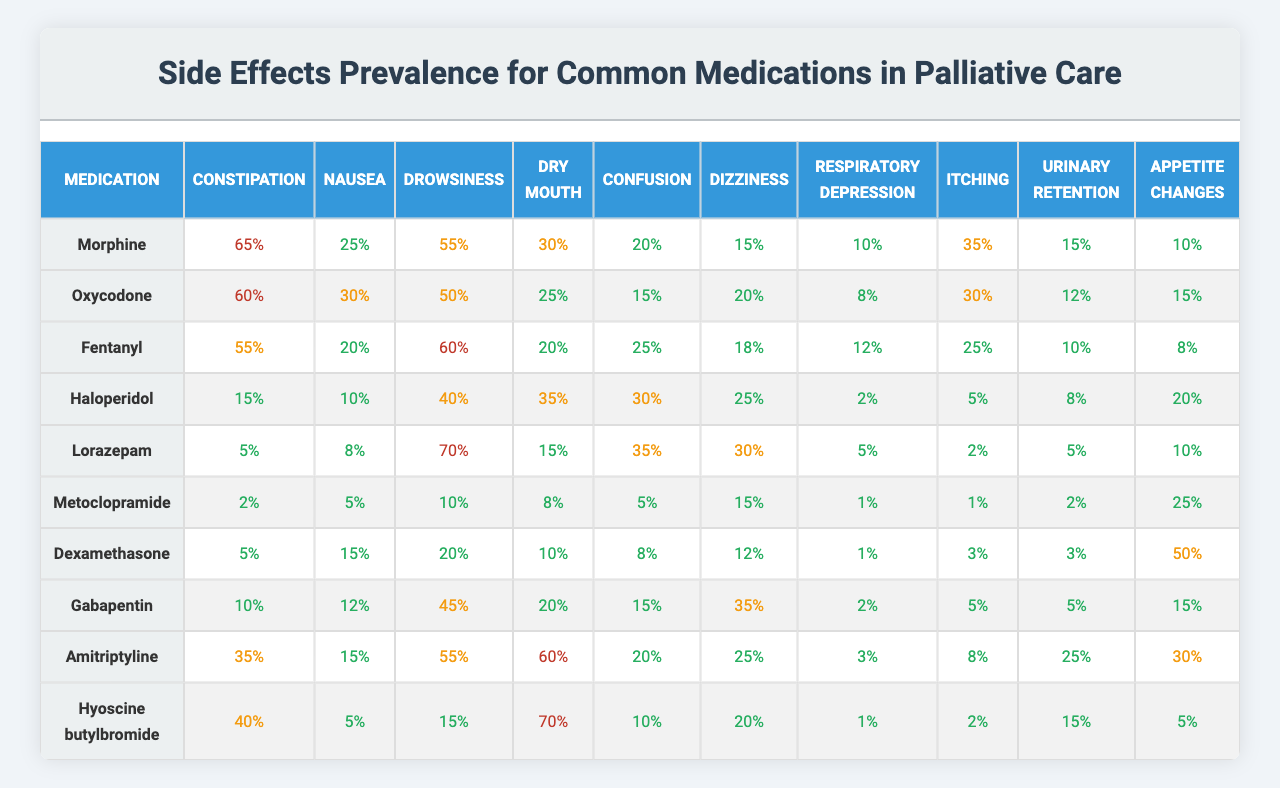What is the prevalence of constipation for Morphine? The table indicates that the prevalence of constipation for Morphine is 65%.
Answer: 65% Which medication has the highest prevalence of drowsiness? By checking the drowsiness values across all medications, Fentanyl has the highest prevalence at 60%.
Answer: Fentanyl Does Lorazepam cause more nausea than Metoclopramide? The table shows that Lorazepam has a prevalence of nausea at 8%, while Metoclopramide has a prevalence of 5%. Therefore, yes, Lorazepam causes more nausea.
Answer: Yes What is the total prevalence of respiratory depression for both Morphine and Oxycodone? The prevalence of respiratory depression for Morphine is 10%, and for Oxycodone is 8%. Adding these gives 10% + 8% = 18%.
Answer: 18% Which medication has the lowest prevalence of appetite changes, and what is that percentage? Reviewing the table, Metoclopramide has the lowest prevalence of appetite changes at 25%.
Answer: Metoclopramide, 25% Calculate the average prevalence of confusion across all medications. The values for confusion are: 20, 15, 25, 30, 35, 5, 8, 15, 20, and 10. Summing these gives 20 + 15 + 25 + 30 + 35 + 5 + 8 + 15 + 20 + 10 =  3. The average is then calculated as the total (180) divided by the number of medications (10), which is 18%.
Answer: 18% Is drowsiness more prevalent in Amitriptyline or Gabapentin? Amitriptyline has a drowsiness prevalence of 55%, whereas Gabapentin's is 45%. Comparing these figures shows that Amitriptyline has a higher prevalence.
Answer: Amitriptyline What is the prevalence of dry mouth for Hyoscine butylbromide? According to the table, Hyoscine butylbromide has a prevalence of dry mouth at 70%.
Answer: 70% Which medication has a prevalence of urinary retention lower than 10%? Looking at the urinary retention values, both Fentanyl (10%) and Dexamethasone (3%) have lower prevalence levels, meaning only Dexamethasone fits the criteria.
Answer: Dexamethasone What is the difference in the prevalence of itching between Oxycodone and Haloperidol? The prevalence of itching for Oxycodone is 30%, and for Haloperidol, it is 5%. The difference is 30% - 5% = 25%.
Answer: 25% 